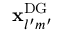Convert formula to latex. <formula><loc_0><loc_0><loc_500><loc_500>x _ { l ^ { \prime } m ^ { \prime } } ^ { D G }</formula> 